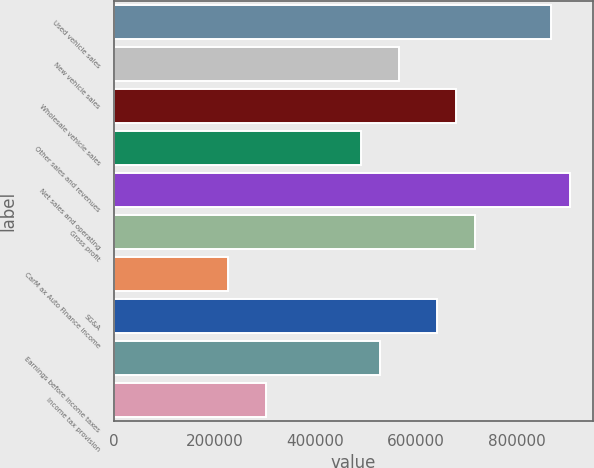Convert chart. <chart><loc_0><loc_0><loc_500><loc_500><bar_chart><fcel>Used vehicle sales<fcel>New vehicle sales<fcel>Wholesale vehicle sales<fcel>Other sales and revenues<fcel>Net sales and operating<fcel>Gross profit<fcel>CarM ax Auto Finance income<fcel>SG&A<fcel>Earnings before income taxes<fcel>Income tax provision<nl><fcel>867657<fcel>565864<fcel>679037<fcel>490416<fcel>905381<fcel>716761<fcel>226348<fcel>641313<fcel>528140<fcel>301796<nl></chart> 